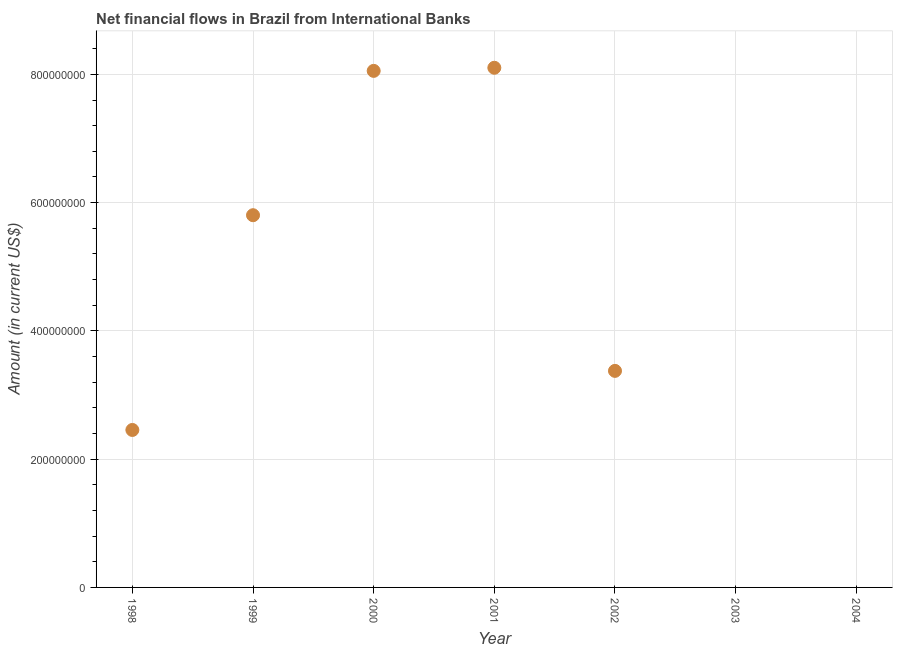What is the net financial flows from ibrd in 1999?
Provide a short and direct response. 5.80e+08. Across all years, what is the maximum net financial flows from ibrd?
Offer a terse response. 8.10e+08. What is the sum of the net financial flows from ibrd?
Your response must be concise. 2.78e+09. What is the difference between the net financial flows from ibrd in 1998 and 1999?
Your answer should be compact. -3.35e+08. What is the average net financial flows from ibrd per year?
Give a very brief answer. 3.97e+08. What is the median net financial flows from ibrd?
Your answer should be compact. 3.38e+08. What is the ratio of the net financial flows from ibrd in 1998 to that in 1999?
Make the answer very short. 0.42. Is the net financial flows from ibrd in 1998 less than that in 2000?
Offer a very short reply. Yes. Is the difference between the net financial flows from ibrd in 1999 and 2002 greater than the difference between any two years?
Offer a very short reply. No. What is the difference between the highest and the second highest net financial flows from ibrd?
Offer a very short reply. 4.84e+06. What is the difference between the highest and the lowest net financial flows from ibrd?
Offer a terse response. 8.10e+08. In how many years, is the net financial flows from ibrd greater than the average net financial flows from ibrd taken over all years?
Offer a very short reply. 3. Does the net financial flows from ibrd monotonically increase over the years?
Your response must be concise. No. How many dotlines are there?
Give a very brief answer. 1. How many years are there in the graph?
Give a very brief answer. 7. Are the values on the major ticks of Y-axis written in scientific E-notation?
Your answer should be very brief. No. Does the graph contain any zero values?
Make the answer very short. Yes. What is the title of the graph?
Provide a succinct answer. Net financial flows in Brazil from International Banks. What is the label or title of the X-axis?
Provide a short and direct response. Year. What is the label or title of the Y-axis?
Your answer should be very brief. Amount (in current US$). What is the Amount (in current US$) in 1998?
Offer a terse response. 2.46e+08. What is the Amount (in current US$) in 1999?
Make the answer very short. 5.80e+08. What is the Amount (in current US$) in 2000?
Offer a terse response. 8.05e+08. What is the Amount (in current US$) in 2001?
Offer a terse response. 8.10e+08. What is the Amount (in current US$) in 2002?
Provide a succinct answer. 3.38e+08. What is the difference between the Amount (in current US$) in 1998 and 1999?
Keep it short and to the point. -3.35e+08. What is the difference between the Amount (in current US$) in 1998 and 2000?
Offer a very short reply. -5.60e+08. What is the difference between the Amount (in current US$) in 1998 and 2001?
Provide a succinct answer. -5.65e+08. What is the difference between the Amount (in current US$) in 1998 and 2002?
Provide a succinct answer. -9.21e+07. What is the difference between the Amount (in current US$) in 1999 and 2000?
Keep it short and to the point. -2.25e+08. What is the difference between the Amount (in current US$) in 1999 and 2001?
Ensure brevity in your answer.  -2.30e+08. What is the difference between the Amount (in current US$) in 1999 and 2002?
Offer a terse response. 2.43e+08. What is the difference between the Amount (in current US$) in 2000 and 2001?
Provide a succinct answer. -4.84e+06. What is the difference between the Amount (in current US$) in 2000 and 2002?
Keep it short and to the point. 4.68e+08. What is the difference between the Amount (in current US$) in 2001 and 2002?
Offer a terse response. 4.73e+08. What is the ratio of the Amount (in current US$) in 1998 to that in 1999?
Provide a short and direct response. 0.42. What is the ratio of the Amount (in current US$) in 1998 to that in 2000?
Provide a succinct answer. 0.3. What is the ratio of the Amount (in current US$) in 1998 to that in 2001?
Make the answer very short. 0.3. What is the ratio of the Amount (in current US$) in 1998 to that in 2002?
Provide a short and direct response. 0.73. What is the ratio of the Amount (in current US$) in 1999 to that in 2000?
Ensure brevity in your answer.  0.72. What is the ratio of the Amount (in current US$) in 1999 to that in 2001?
Make the answer very short. 0.72. What is the ratio of the Amount (in current US$) in 1999 to that in 2002?
Provide a short and direct response. 1.72. What is the ratio of the Amount (in current US$) in 2000 to that in 2001?
Give a very brief answer. 0.99. What is the ratio of the Amount (in current US$) in 2000 to that in 2002?
Your response must be concise. 2.38. 